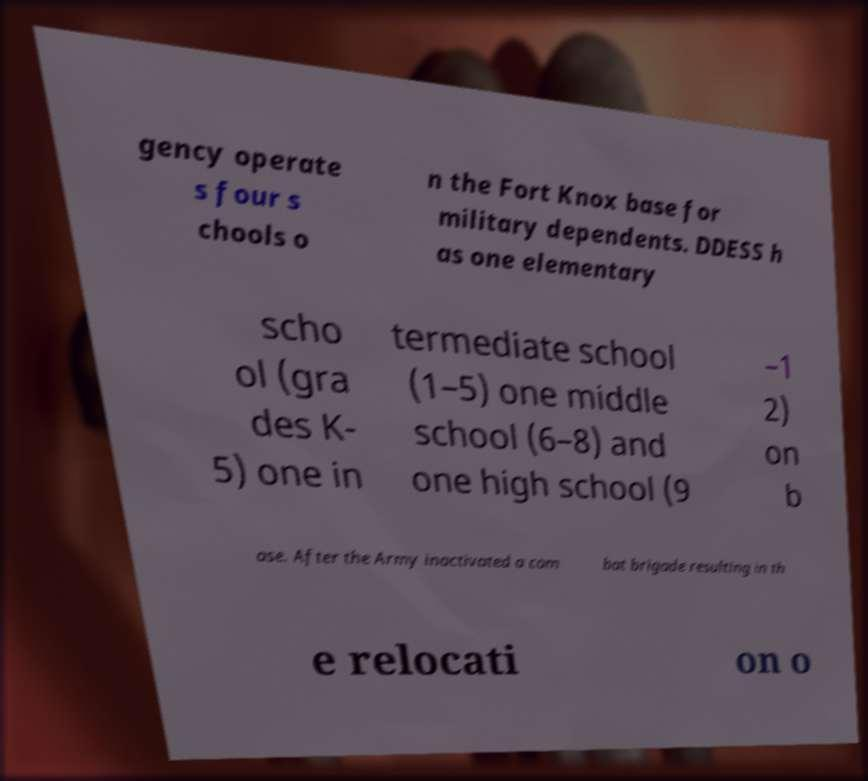Can you accurately transcribe the text from the provided image for me? gency operate s four s chools o n the Fort Knox base for military dependents. DDESS h as one elementary scho ol (gra des K- 5) one in termediate school (1–5) one middle school (6–8) and one high school (9 –1 2) on b ase. After the Army inactivated a com bat brigade resulting in th e relocati on o 